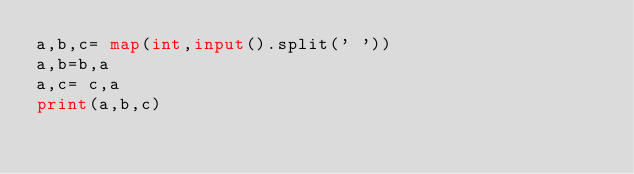Convert code to text. <code><loc_0><loc_0><loc_500><loc_500><_Python_>a,b,c= map(int,input().split(' '))
a,b=b,a
a,c= c,a
print(a,b,c)</code> 